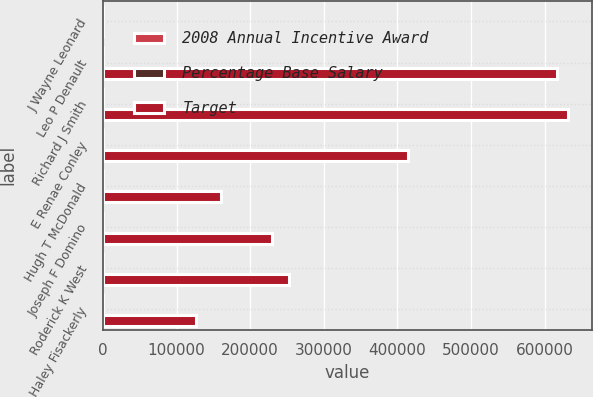<chart> <loc_0><loc_0><loc_500><loc_500><stacked_bar_chart><ecel><fcel>J Wayne Leonard<fcel>Leo P Denault<fcel>Richard J Smith<fcel>E Renae Conley<fcel>Hugh T McDonald<fcel>Joseph F Domino<fcel>Roderick K West<fcel>Haley Fisackerly<nl><fcel>2008 Annual Incentive Award<fcel>120<fcel>70<fcel>70<fcel>60<fcel>50<fcel>50<fcel>40<fcel>40<nl><fcel>Percentage Base Salary<fcel>168<fcel>98<fcel>98<fcel>102<fcel>50<fcel>72<fcel>80<fcel>46<nl><fcel>Target<fcel>98<fcel>617400<fcel>632100<fcel>415000<fcel>160500<fcel>230000<fcel>252000<fcel>125700<nl></chart> 